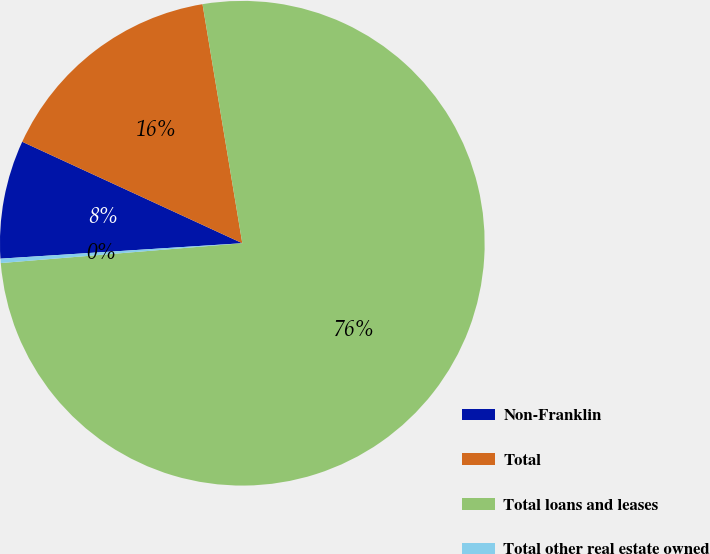<chart> <loc_0><loc_0><loc_500><loc_500><pie_chart><fcel>Non-Franklin<fcel>Total<fcel>Total loans and leases<fcel>Total other real estate owned<nl><fcel>7.89%<fcel>15.5%<fcel>76.32%<fcel>0.29%<nl></chart> 